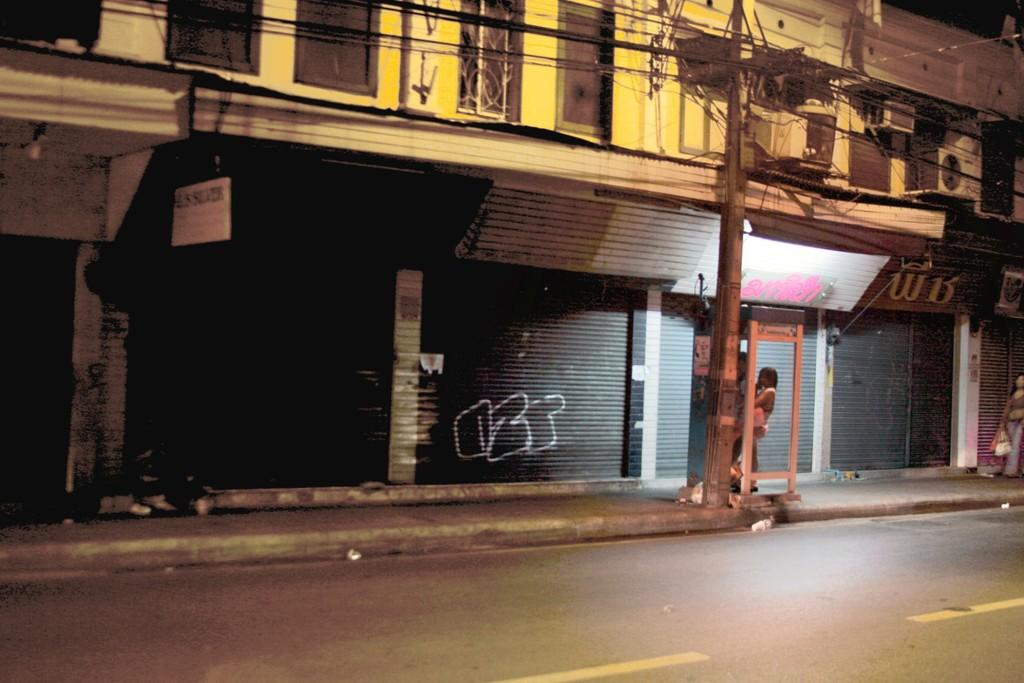Where was the image taken? The image was clicked outside. What can be seen in the middle of the image? There are buildings and shops in the middle of the image. Is there a person visible in the image? Yes, there is a person in the middle of the image. What is the person doing in the image? The person is standing in the image. What else is present in the middle of the image? There is a pole in the middle of the image. What type of chair is the person sitting on in the image? There is no chair present in the image; the person is standing. How does the person play with the pole in the image? The person is not playing with the pole in the image; they are simply standing near it. 